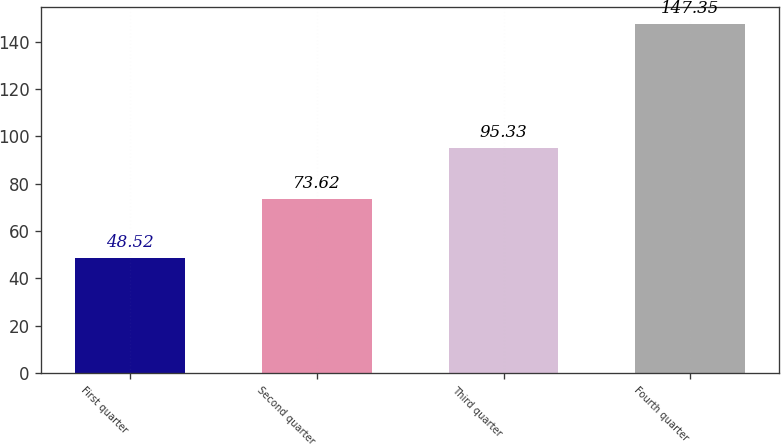Convert chart to OTSL. <chart><loc_0><loc_0><loc_500><loc_500><bar_chart><fcel>First quarter<fcel>Second quarter<fcel>Third quarter<fcel>Fourth quarter<nl><fcel>48.52<fcel>73.62<fcel>95.33<fcel>147.35<nl></chart> 